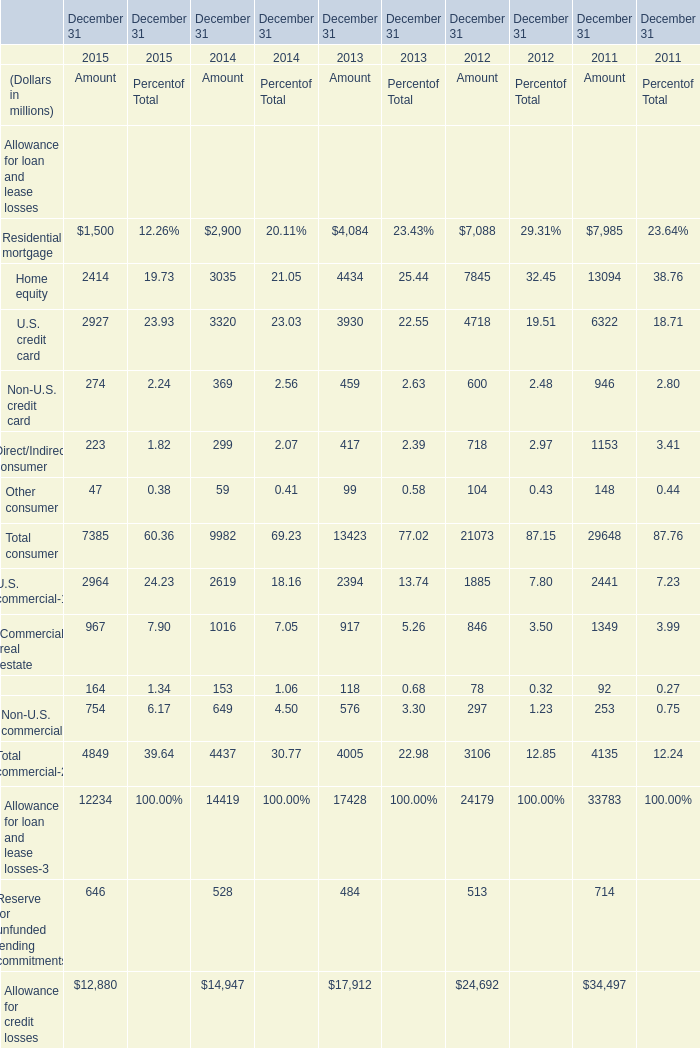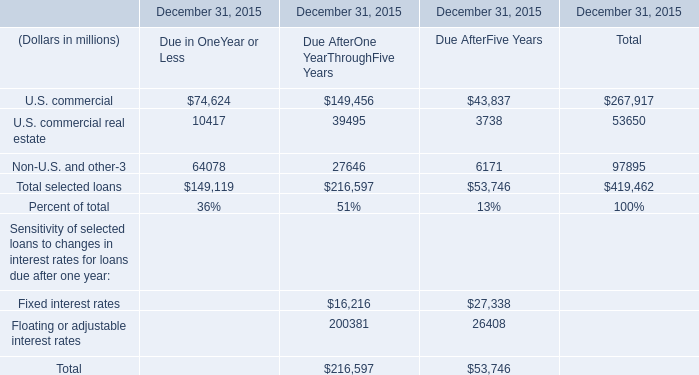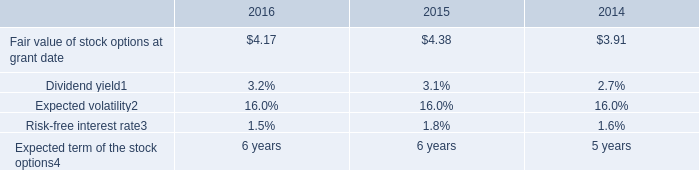What is the average amount of Allowance for credit losses of December 31 2012 Amount, and U.S. commercial of December 31, 2015 Due AfterFive Years ? 
Computations: ((24692.0 + 43837.0) / 2)
Answer: 34264.5. 